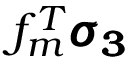Convert formula to latex. <formula><loc_0><loc_0><loc_500><loc_500>f _ { m } ^ { T } \pm b { \sigma _ { 3 } }</formula> 